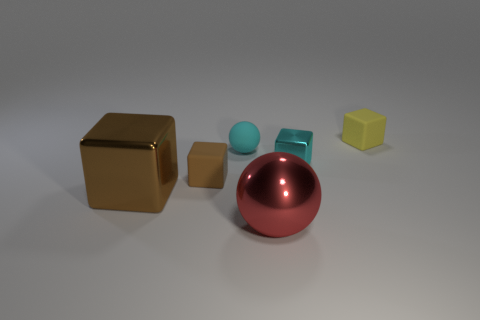Add 3 brown blocks. How many objects exist? 9 Subtract all green cubes. Subtract all cyan balls. How many cubes are left? 4 Subtract all cubes. How many objects are left? 2 Subtract 0 red cylinders. How many objects are left? 6 Subtract all brown objects. Subtract all spheres. How many objects are left? 2 Add 3 big brown shiny objects. How many big brown shiny objects are left? 4 Add 4 cyan blocks. How many cyan blocks exist? 5 